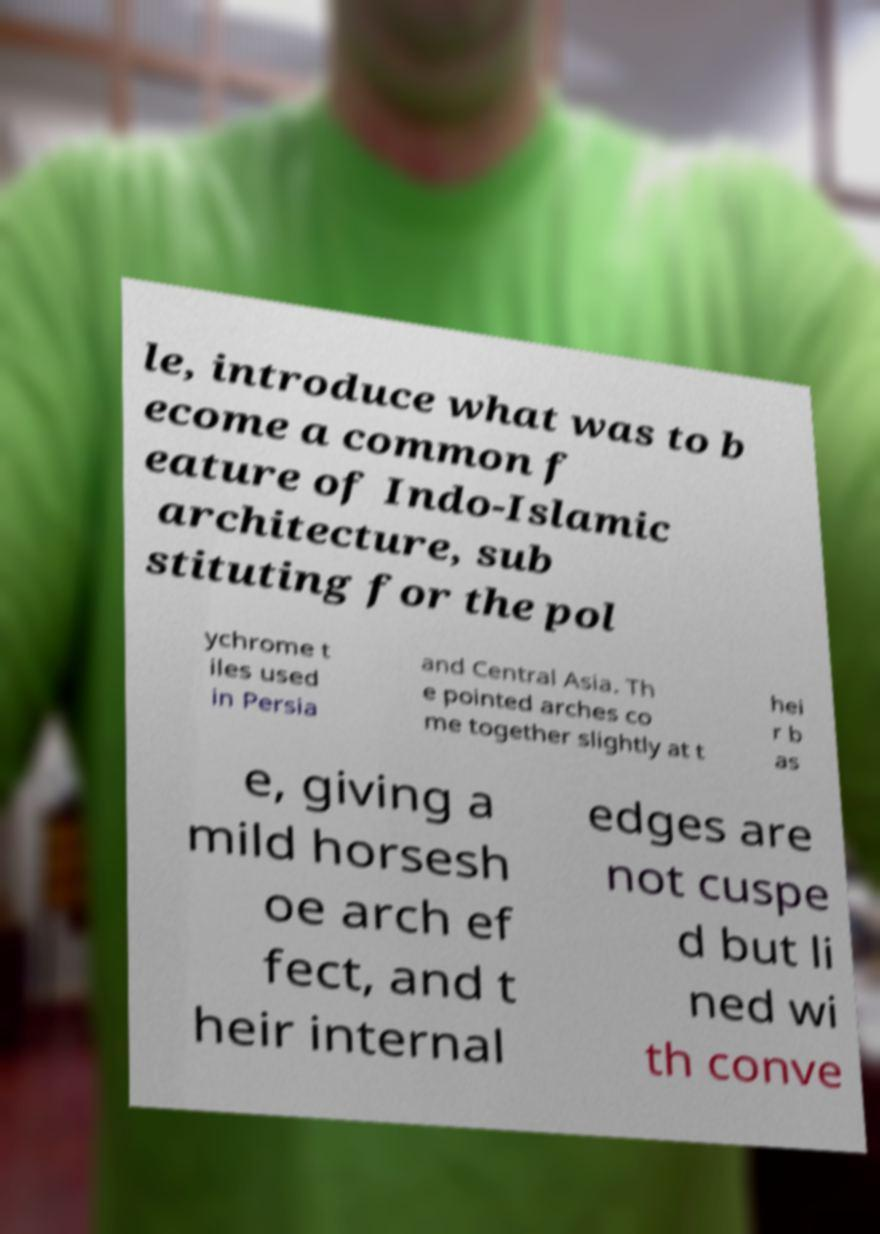Could you extract and type out the text from this image? le, introduce what was to b ecome a common f eature of Indo-Islamic architecture, sub stituting for the pol ychrome t iles used in Persia and Central Asia. Th e pointed arches co me together slightly at t hei r b as e, giving a mild horsesh oe arch ef fect, and t heir internal edges are not cuspe d but li ned wi th conve 